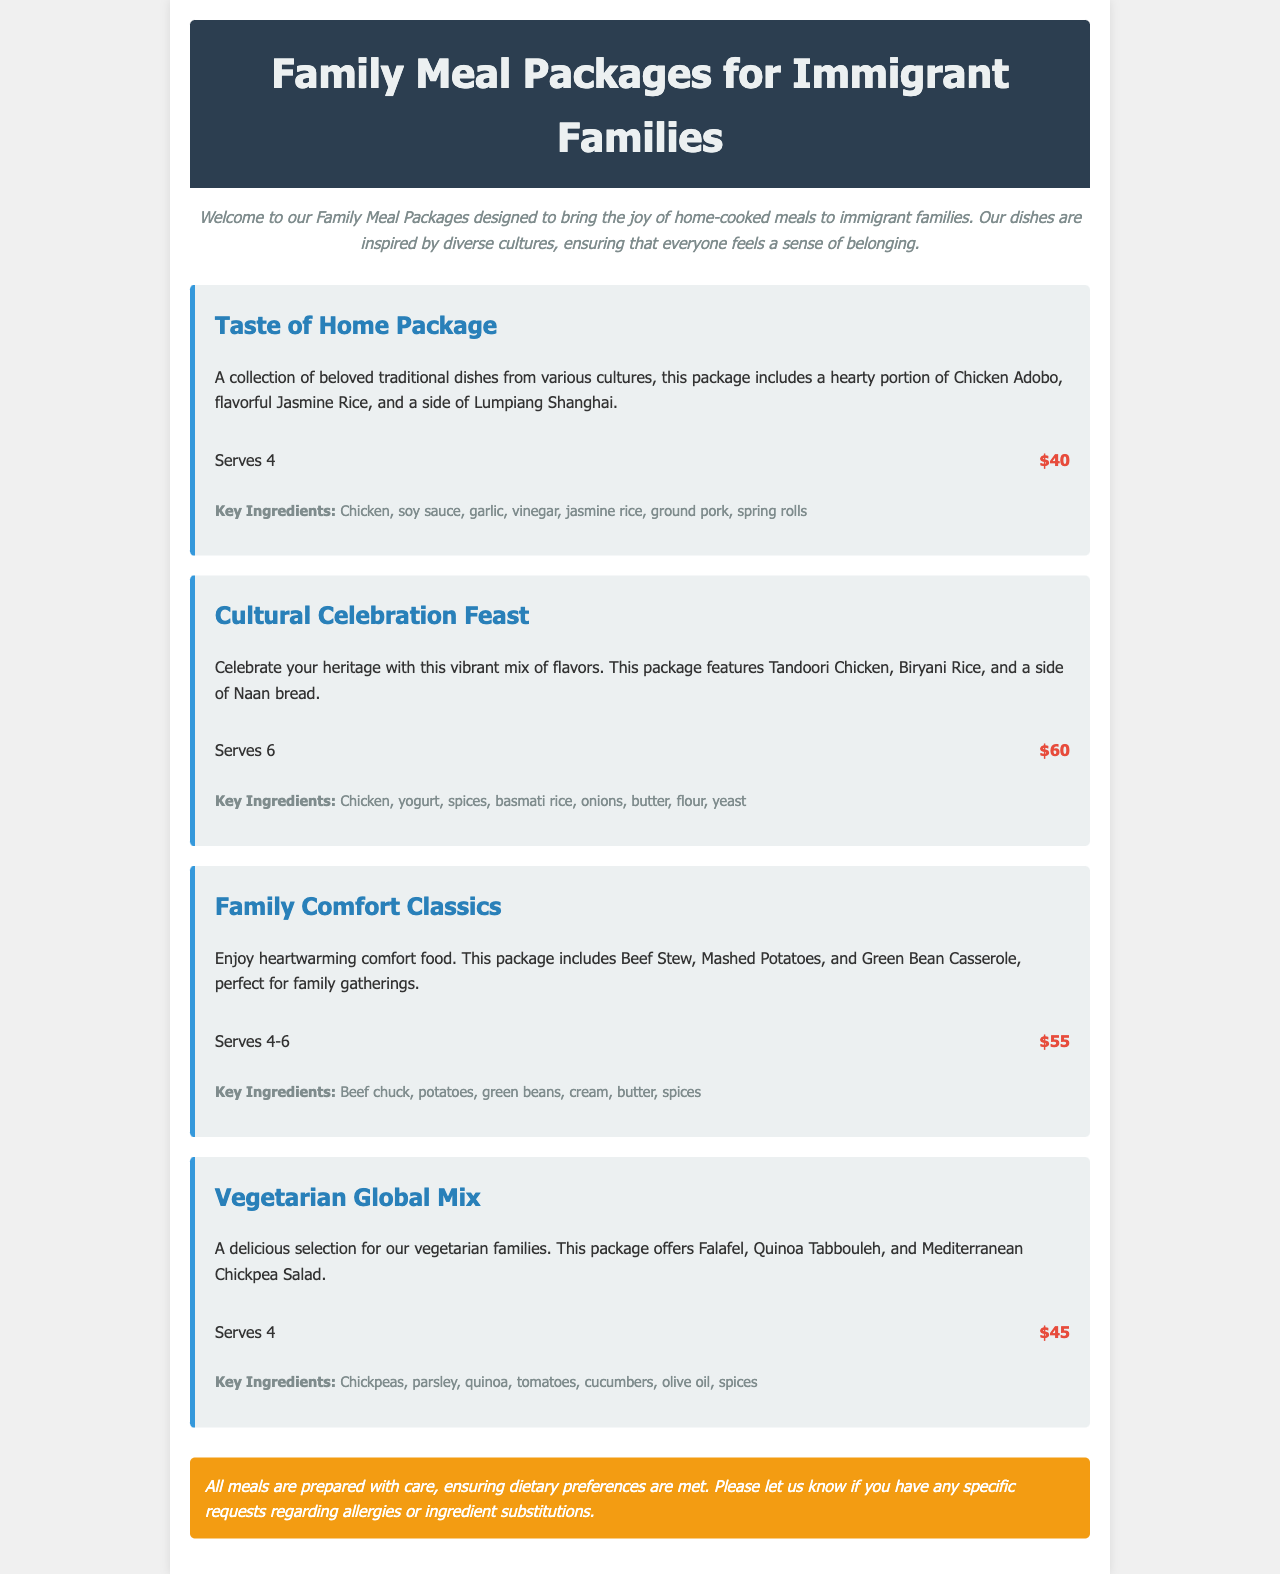What is the price of the Taste of Home Package? The price for the Taste of Home Package is mentioned under its details as $40.
Answer: $40 How many servings does the Cultural Celebration Feast provide? The number of servings for the Cultural Celebration Feast is indicated in the meal info section as serving 6.
Answer: 6 What are the key ingredients in the Vegetarian Global Mix? The key ingredients for the Vegetarian Global Mix are listed in the ingredients section, including chickpeas, parsley, quinoa, tomatoes, cucumbers, olive oil, and spices.
Answer: Chickpeas, parsley, quinoa, tomatoes, cucumbers, olive oil, spices Which meal package serves the most people? The meal package that serves the most people is the Cultural Celebration Feast, which serves 6.
Answer: Cultural Celebration Feast What dish is included in the Family Comfort Classics package? The Family Comfort Classics package includes Beef Stew, which is specified in the description of the meal.
Answer: Beef Stew Is there a note regarding dietary preferences? Yes, the note specifies that all meals meet dietary preferences and encourages requests regarding allergies or ingredient substitutions.
Answer: Yes 